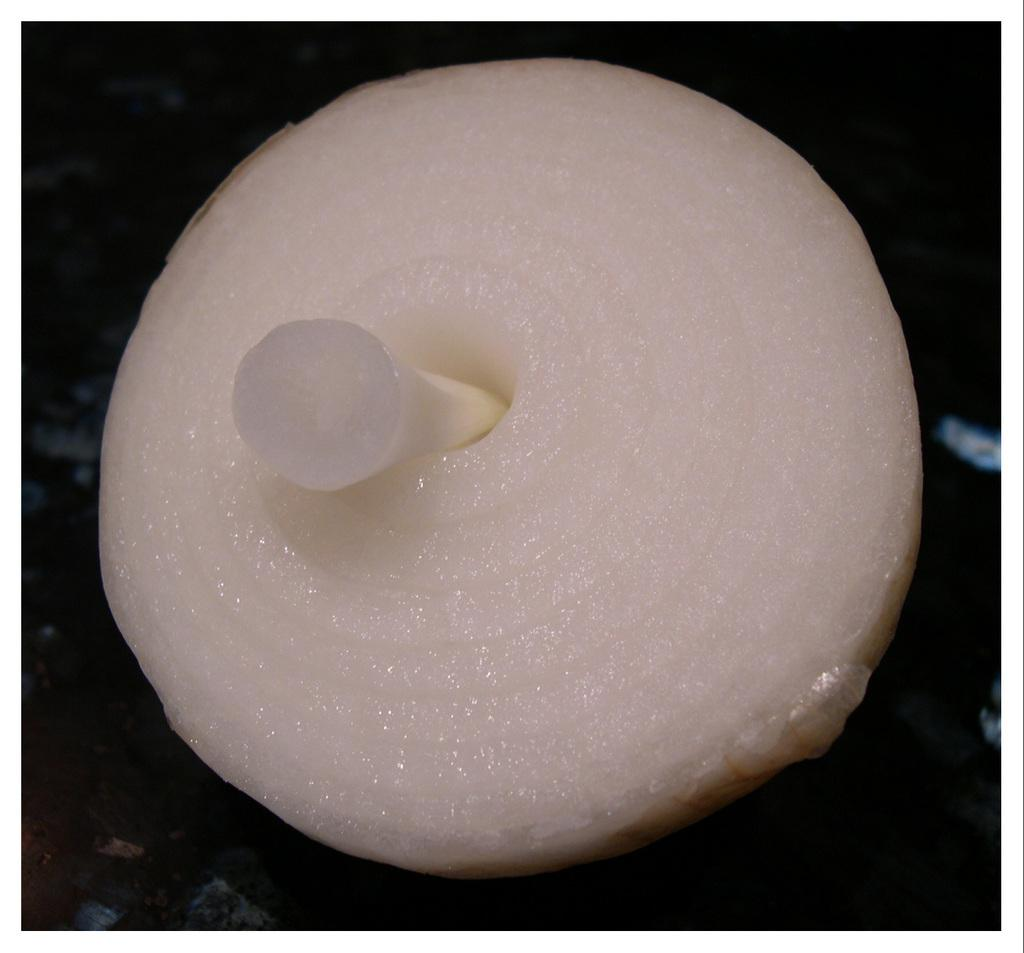What is the main subject of the image? The main subject of the image is an onion. Can you describe the location of the onion in the image? The onion is present over a place, but the specific location is not mentioned in the facts. How many horses can be seen grazing near the onion in the image? There is no mention of horses in the image, so it is not possible to determine their presence or number. 